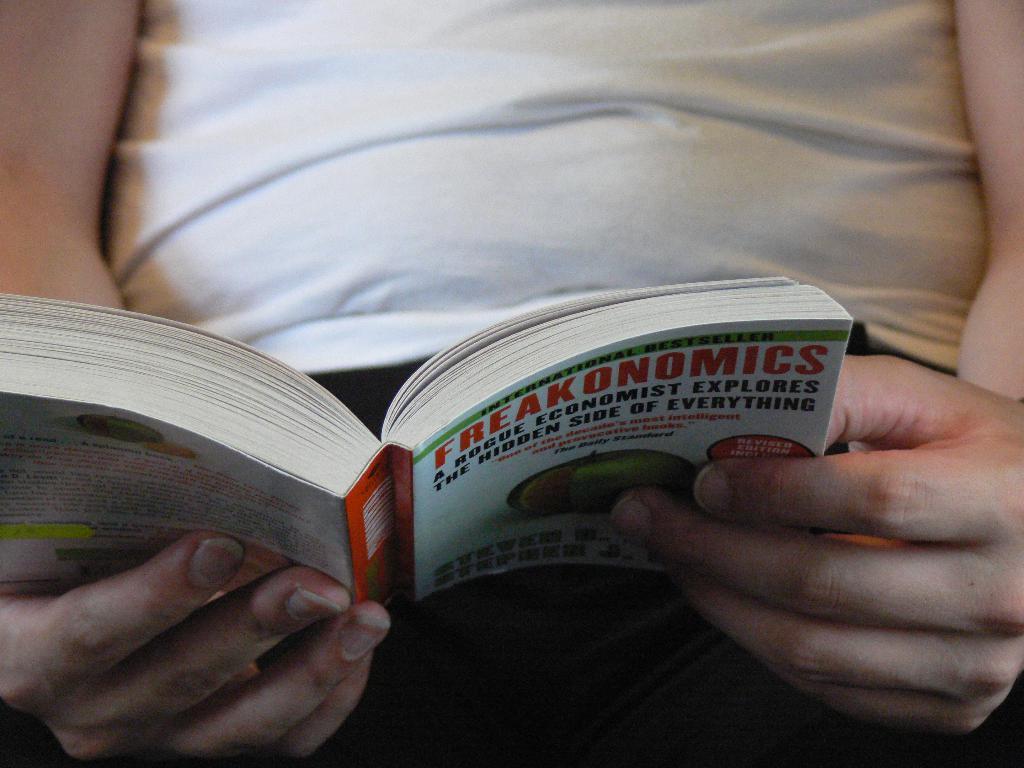'freakonomics' is a book written by a rogue what?
Make the answer very short. Economist. What is the title of this book?
Provide a short and direct response. Freakonomics. 